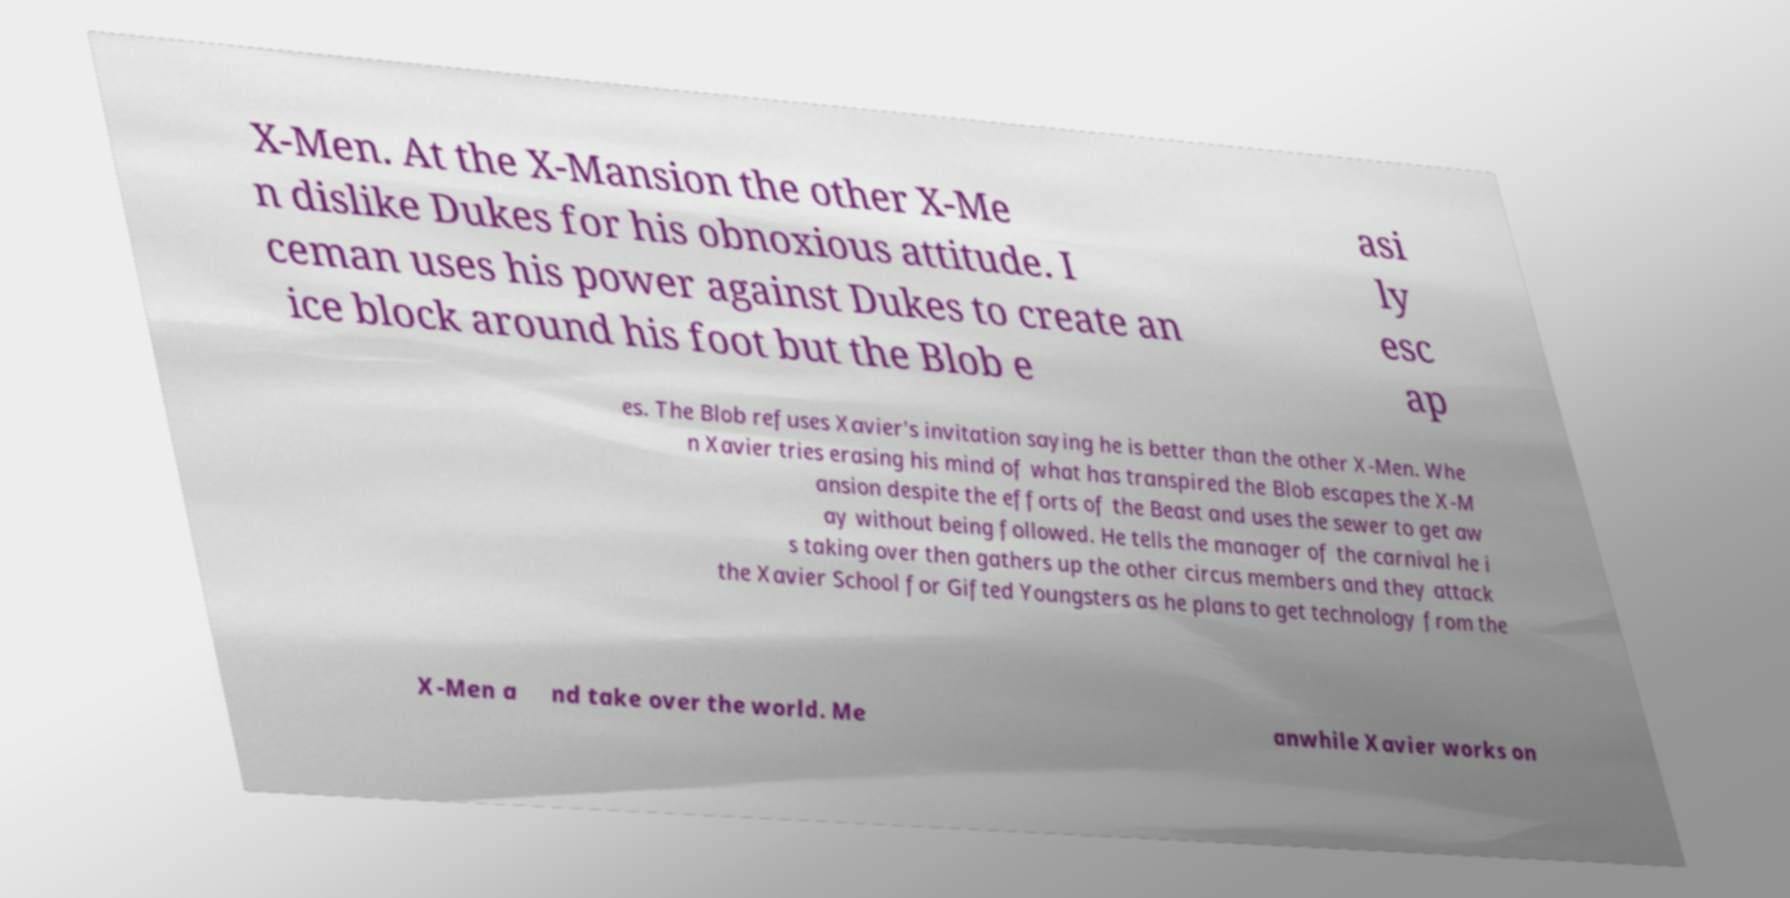For documentation purposes, I need the text within this image transcribed. Could you provide that? X-Men. At the X-Mansion the other X-Me n dislike Dukes for his obnoxious attitude. I ceman uses his power against Dukes to create an ice block around his foot but the Blob e asi ly esc ap es. The Blob refuses Xavier's invitation saying he is better than the other X-Men. Whe n Xavier tries erasing his mind of what has transpired the Blob escapes the X-M ansion despite the efforts of the Beast and uses the sewer to get aw ay without being followed. He tells the manager of the carnival he i s taking over then gathers up the other circus members and they attack the Xavier School for Gifted Youngsters as he plans to get technology from the X-Men a nd take over the world. Me anwhile Xavier works on 